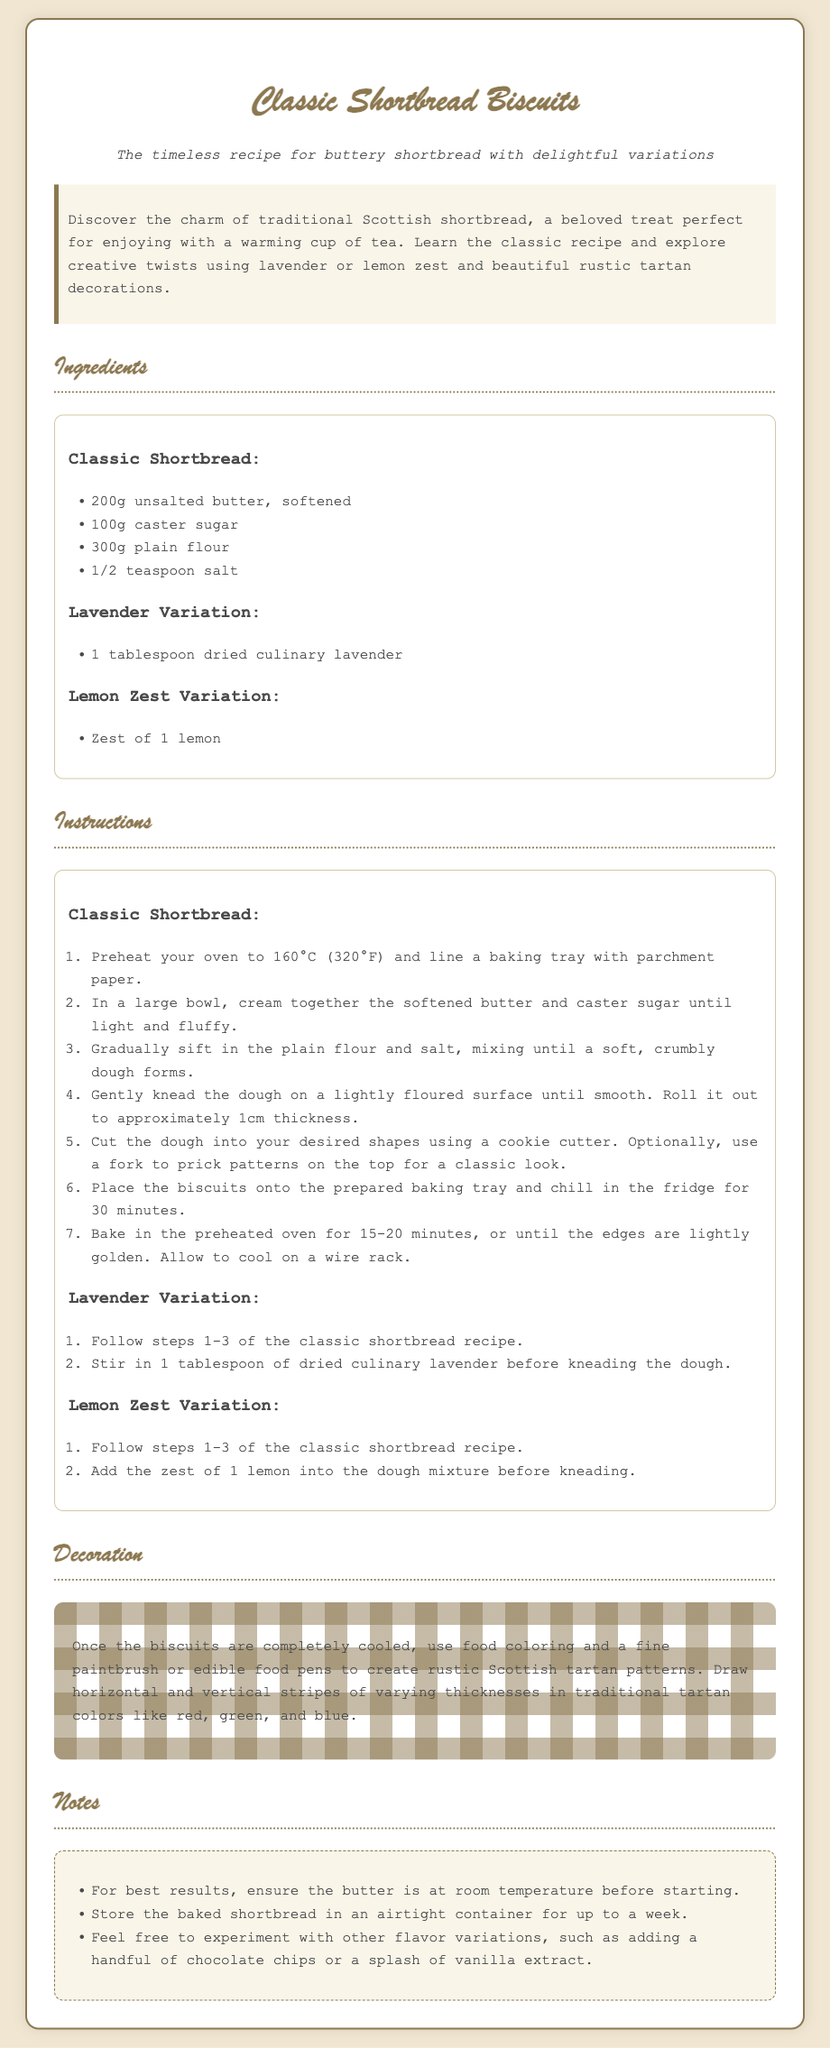what is the main type of biscuit? The recipe card specifies that the main type of biscuit is shortbread.
Answer: shortbread what is the total weight of plain flour required? The ingredients section lists that 300g of plain flour is needed for the classic shortbread recipe.
Answer: 300g how long should the biscuits be chilled in the fridge? The instructions state that the biscuits should be chilled in the fridge for 30 minutes before baking.
Answer: 30 minutes what is one variation mentioned for flavoring the biscuits? The recipe card mentions a lavender variation that includes dried culinary lavender as an ingredient.
Answer: lavender how long should the biscuits be baked for? According to the instructions, the biscuits should be baked for 15-20 minutes in the oven.
Answer: 15-20 minutes what temperature should the oven be set to? The instructions indicate that the oven should be preheated to 160°C (320°F).
Answer: 160°C what decorative pattern is suggested for the biscuits? The decoration section describes creating rustic Scottish tartan patterns on the biscuits.
Answer: tartan patterns how should the butter be prepared before starting? The notes section advises that the butter should be at room temperature before beginning the recipe.
Answer: room temperature 